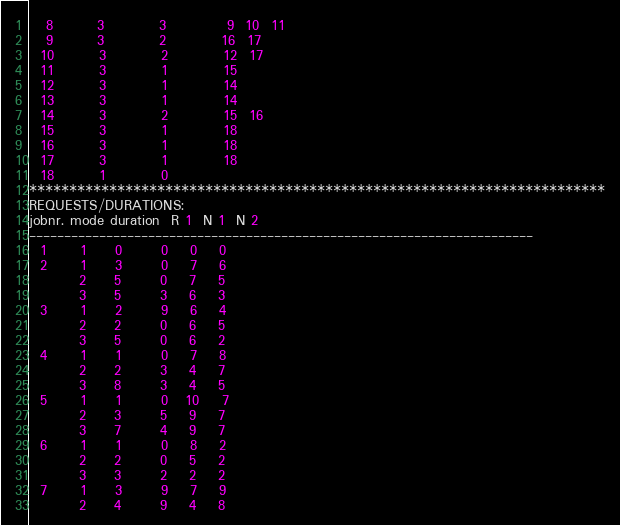Convert code to text. <code><loc_0><loc_0><loc_500><loc_500><_ObjectiveC_>   8        3          3           9  10  11
   9        3          2          16  17
  10        3          2          12  17
  11        3          1          15
  12        3          1          14
  13        3          1          14
  14        3          2          15  16
  15        3          1          18
  16        3          1          18
  17        3          1          18
  18        1          0        
************************************************************************
REQUESTS/DURATIONS:
jobnr. mode duration  R 1  N 1  N 2
------------------------------------------------------------------------
  1      1     0       0    0    0
  2      1     3       0    7    6
         2     5       0    7    5
         3     5       3    6    3
  3      1     2       9    6    4
         2     2       0    6    5
         3     5       0    6    2
  4      1     1       0    7    8
         2     2       3    4    7
         3     8       3    4    5
  5      1     1       0   10    7
         2     3       5    9    7
         3     7       4    9    7
  6      1     1       0    8    2
         2     2       0    5    2
         3     3       2    2    2
  7      1     3       9    7    9
         2     4       9    4    8</code> 